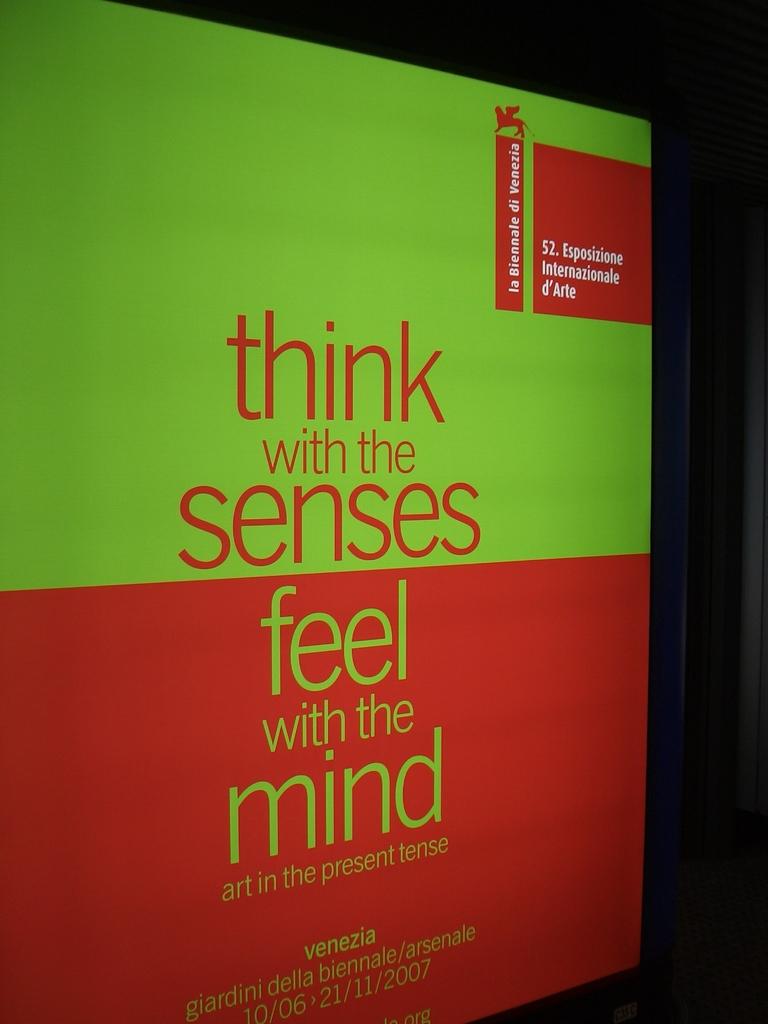What should you think with?
Ensure brevity in your answer.  Senses. You should think with the senses, but you should feel with what?
Your answer should be very brief. Mind. 